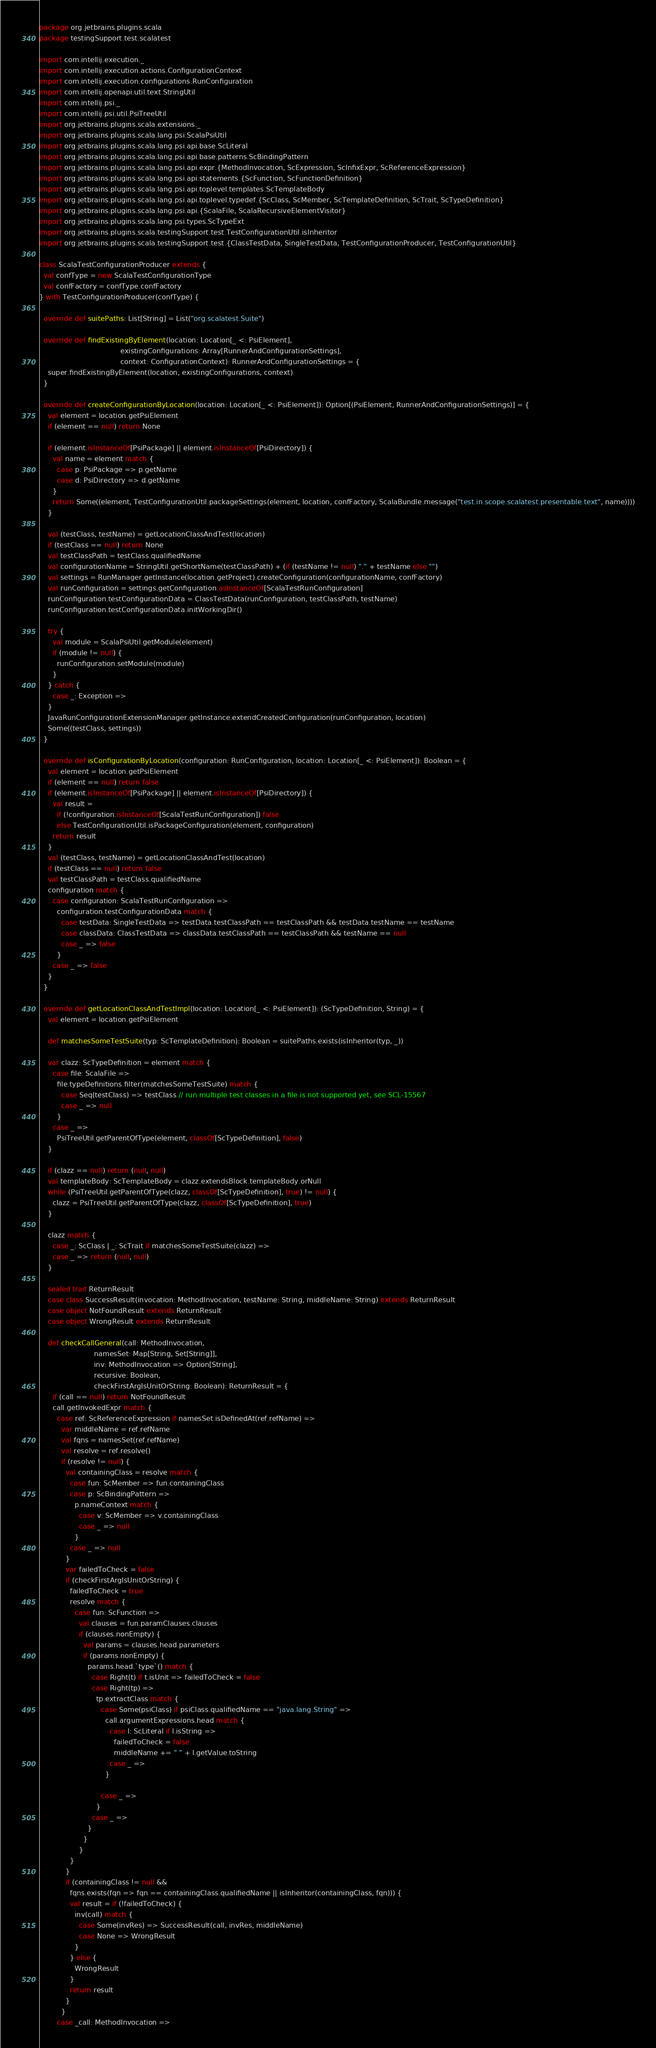<code> <loc_0><loc_0><loc_500><loc_500><_Scala_>package org.jetbrains.plugins.scala
package testingSupport.test.scalatest

import com.intellij.execution._
import com.intellij.execution.actions.ConfigurationContext
import com.intellij.execution.configurations.RunConfiguration
import com.intellij.openapi.util.text.StringUtil
import com.intellij.psi._
import com.intellij.psi.util.PsiTreeUtil
import org.jetbrains.plugins.scala.extensions._
import org.jetbrains.plugins.scala.lang.psi.ScalaPsiUtil
import org.jetbrains.plugins.scala.lang.psi.api.base.ScLiteral
import org.jetbrains.plugins.scala.lang.psi.api.base.patterns.ScBindingPattern
import org.jetbrains.plugins.scala.lang.psi.api.expr.{MethodInvocation, ScExpression, ScInfixExpr, ScReferenceExpression}
import org.jetbrains.plugins.scala.lang.psi.api.statements.{ScFunction, ScFunctionDefinition}
import org.jetbrains.plugins.scala.lang.psi.api.toplevel.templates.ScTemplateBody
import org.jetbrains.plugins.scala.lang.psi.api.toplevel.typedef.{ScClass, ScMember, ScTemplateDefinition, ScTrait, ScTypeDefinition}
import org.jetbrains.plugins.scala.lang.psi.api.{ScalaFile, ScalaRecursiveElementVisitor}
import org.jetbrains.plugins.scala.lang.psi.types.ScTypeExt
import org.jetbrains.plugins.scala.testingSupport.test.TestConfigurationUtil.isInheritor
import org.jetbrains.plugins.scala.testingSupport.test.{ClassTestData, SingleTestData, TestConfigurationProducer, TestConfigurationUtil}

class ScalaTestConfigurationProducer extends {
  val confType = new ScalaTestConfigurationType
  val confFactory = confType.confFactory
} with TestConfigurationProducer(confType) {

  override def suitePaths: List[String] = List("org.scalatest.Suite")

  override def findExistingByElement(location: Location[_ <: PsiElement],
                                     existingConfigurations: Array[RunnerAndConfigurationSettings],
                                     context: ConfigurationContext): RunnerAndConfigurationSettings = {
    super.findExistingByElement(location, existingConfigurations, context)
  }

  override def createConfigurationByLocation(location: Location[_ <: PsiElement]): Option[(PsiElement, RunnerAndConfigurationSettings)] = {
    val element = location.getPsiElement
    if (element == null) return None

    if (element.isInstanceOf[PsiPackage] || element.isInstanceOf[PsiDirectory]) {
      val name = element match {
        case p: PsiPackage => p.getName
        case d: PsiDirectory => d.getName
      }
      return Some((element, TestConfigurationUtil.packageSettings(element, location, confFactory, ScalaBundle.message("test.in.scope.scalatest.presentable.text", name))))
    }

    val (testClass, testName) = getLocationClassAndTest(location)
    if (testClass == null) return None
    val testClassPath = testClass.qualifiedName
    val configurationName = StringUtil.getShortName(testClassPath) + (if (testName != null) "." + testName else "")
    val settings = RunManager.getInstance(location.getProject).createConfiguration(configurationName, confFactory)
    val runConfiguration = settings.getConfiguration.asInstanceOf[ScalaTestRunConfiguration]
    runConfiguration.testConfigurationData = ClassTestData(runConfiguration, testClassPath, testName)
    runConfiguration.testConfigurationData.initWorkingDir()

    try {
      val module = ScalaPsiUtil.getModule(element)
      if (module != null) {
        runConfiguration.setModule(module)
      }
    } catch {
      case _: Exception =>
    }
    JavaRunConfigurationExtensionManager.getInstance.extendCreatedConfiguration(runConfiguration, location)
    Some((testClass, settings))
  }

  override def isConfigurationByLocation(configuration: RunConfiguration, location: Location[_ <: PsiElement]): Boolean = {
    val element = location.getPsiElement
    if (element == null) return false
    if (element.isInstanceOf[PsiPackage] || element.isInstanceOf[PsiDirectory]) {
      val result =
        if (!configuration.isInstanceOf[ScalaTestRunConfiguration]) false
        else TestConfigurationUtil.isPackageConfiguration(element, configuration)
      return result
    }
    val (testClass, testName) = getLocationClassAndTest(location)
    if (testClass == null) return false
    val testClassPath = testClass.qualifiedName
    configuration match {
      case configuration: ScalaTestRunConfiguration =>
        configuration.testConfigurationData match {
          case testData: SingleTestData => testData.testClassPath == testClassPath && testData.testName == testName
          case classData: ClassTestData => classData.testClassPath == testClassPath && testName == null
          case _ => false
        }
      case _ => false
    }
  }

  override def getLocationClassAndTestImpl(location: Location[_ <: PsiElement]): (ScTypeDefinition, String) = {
    val element = location.getPsiElement

    def matchesSomeTestSuite(typ: ScTemplateDefinition): Boolean = suitePaths.exists(isInheritor(typ, _))

    var clazz: ScTypeDefinition = element match {
      case file: ScalaFile =>
        file.typeDefinitions.filter(matchesSomeTestSuite) match {
          case Seq(testClass) => testClass // run multiple test classes in a file is not supported yet, see SCL-15567
          case _ => null
        }
      case _ =>
        PsiTreeUtil.getParentOfType(element, classOf[ScTypeDefinition], false)
    }

    if (clazz == null) return (null, null)
    val templateBody: ScTemplateBody = clazz.extendsBlock.templateBody.orNull
    while (PsiTreeUtil.getParentOfType(clazz, classOf[ScTypeDefinition], true) != null) {
      clazz = PsiTreeUtil.getParentOfType(clazz, classOf[ScTypeDefinition], true)
    }

    clazz match {
      case _: ScClass | _: ScTrait if matchesSomeTestSuite(clazz) =>
      case _ => return (null, null)
    }

    sealed trait ReturnResult
    case class SuccessResult(invocation: MethodInvocation, testName: String, middleName: String) extends ReturnResult
    case object NotFoundResult extends ReturnResult
    case object WrongResult extends ReturnResult

    def checkCallGeneral(call: MethodInvocation,
                         namesSet: Map[String, Set[String]],
                         inv: MethodInvocation => Option[String],
                         recursive: Boolean,
                         checkFirstArgIsUnitOrString: Boolean): ReturnResult = {
      if (call == null) return NotFoundResult
      call.getInvokedExpr match {
        case ref: ScReferenceExpression if namesSet.isDefinedAt(ref.refName) =>
          var middleName = ref.refName
          val fqns = namesSet(ref.refName)
          val resolve = ref.resolve()
          if (resolve != null) {
            val containingClass = resolve match {
              case fun: ScMember => fun.containingClass
              case p: ScBindingPattern =>
                p.nameContext match {
                  case v: ScMember => v.containingClass
                  case _ => null
                }
              case _ => null
            }
            var failedToCheck = false
            if (checkFirstArgIsUnitOrString) {
              failedToCheck = true
              resolve match {
                case fun: ScFunction =>
                  val clauses = fun.paramClauses.clauses
                  if (clauses.nonEmpty) {
                    val params = clauses.head.parameters
                    if (params.nonEmpty) {
                      params.head.`type`() match {
                        case Right(t) if t.isUnit => failedToCheck = false
                        case Right(tp) =>
                          tp.extractClass match {
                            case Some(psiClass) if psiClass.qualifiedName == "java.lang.String" =>
                              call.argumentExpressions.head match {
                                case l: ScLiteral if l.isString =>
                                  failedToCheck = false
                                  middleName += " " + l.getValue.toString
                                case _ =>
                              }

                            case _ =>
                          }
                        case _ =>
                      }
                    }
                  }
              }
            }
            if (containingClass != null &&
              fqns.exists(fqn => fqn == containingClass.qualifiedName || isInheritor(containingClass, fqn))) {
              val result = if (!failedToCheck) {
                inv(call) match {
                  case Some(invRes) => SuccessResult(call, invRes, middleName)
                  case None => WrongResult
                }
              } else {
                WrongResult
              }
              return result
            }
          }
        case _call: MethodInvocation =></code> 